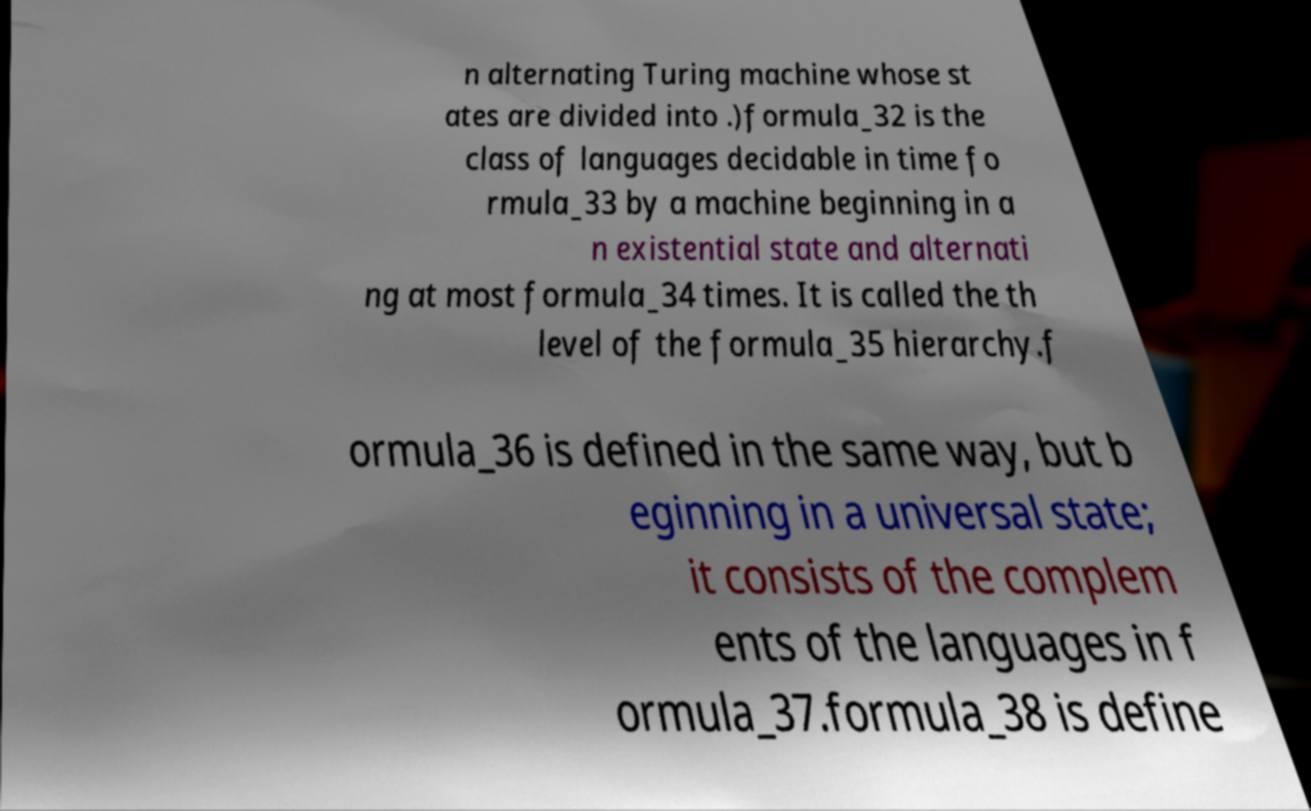There's text embedded in this image that I need extracted. Can you transcribe it verbatim? n alternating Turing machine whose st ates are divided into .)formula_32 is the class of languages decidable in time fo rmula_33 by a machine beginning in a n existential state and alternati ng at most formula_34 times. It is called the th level of the formula_35 hierarchy.f ormula_36 is defined in the same way, but b eginning in a universal state; it consists of the complem ents of the languages in f ormula_37.formula_38 is define 